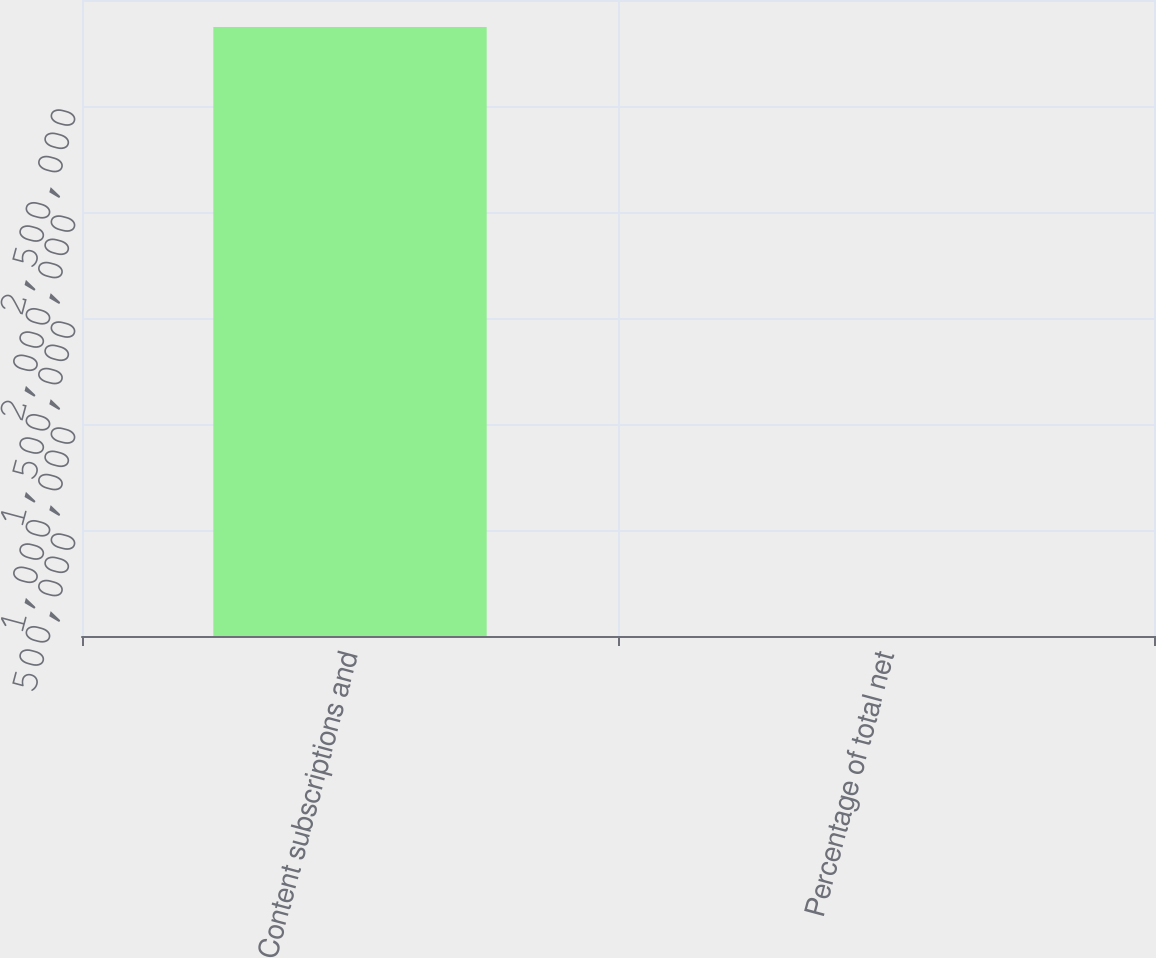<chart> <loc_0><loc_0><loc_500><loc_500><bar_chart><fcel>Content subscriptions and<fcel>Percentage of total net<nl><fcel>2.87321e+06<fcel>69<nl></chart> 